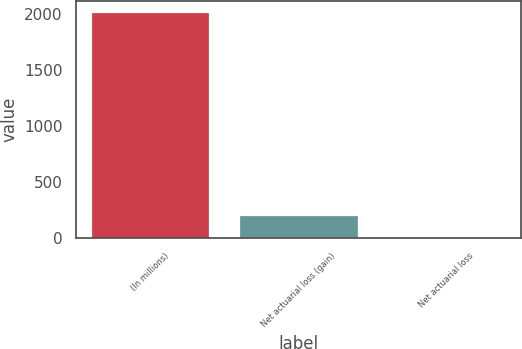Convert chart to OTSL. <chart><loc_0><loc_0><loc_500><loc_500><bar_chart><fcel>(In millions)<fcel>Net actuarial loss (gain)<fcel>Net actuarial loss<nl><fcel>2018<fcel>209<fcel>8<nl></chart> 